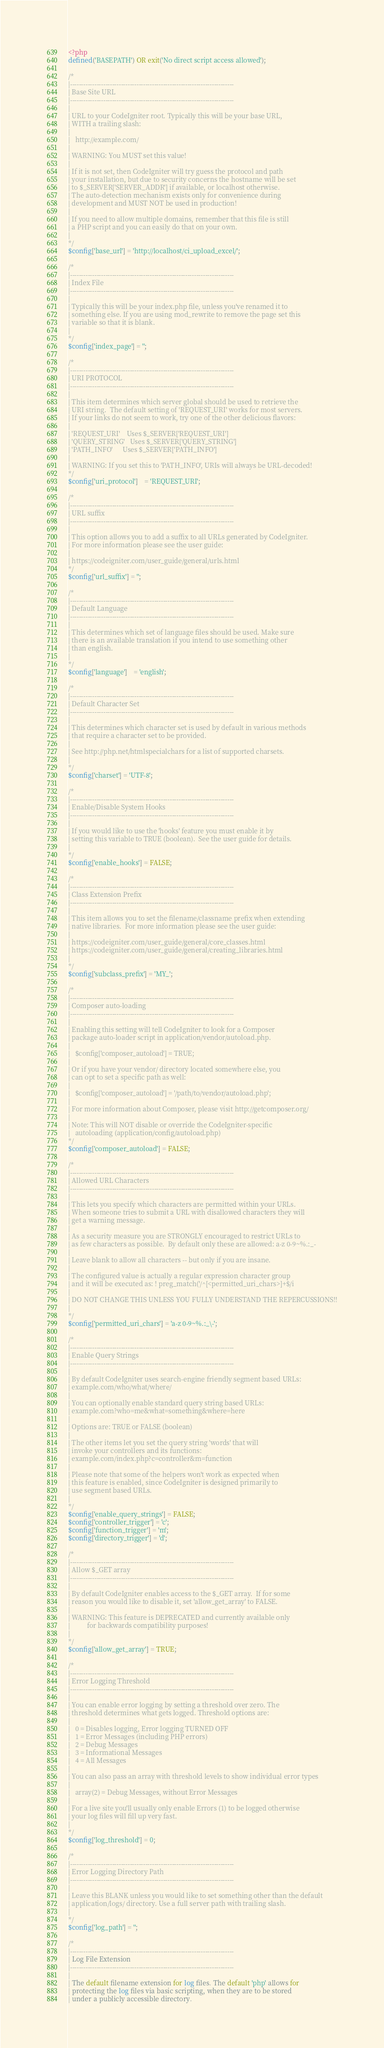Convert code to text. <code><loc_0><loc_0><loc_500><loc_500><_PHP_><?php
defined('BASEPATH') OR exit('No direct script access allowed');

/*
|--------------------------------------------------------------------------
| Base Site URL
|--------------------------------------------------------------------------
|
| URL to your CodeIgniter root. Typically this will be your base URL,
| WITH a trailing slash:
|
|	http://example.com/
|
| WARNING: You MUST set this value!
|
| If it is not set, then CodeIgniter will try guess the protocol and path
| your installation, but due to security concerns the hostname will be set
| to $_SERVER['SERVER_ADDR'] if available, or localhost otherwise.
| The auto-detection mechanism exists only for convenience during
| development and MUST NOT be used in production!
|
| If you need to allow multiple domains, remember that this file is still
| a PHP script and you can easily do that on your own.
|
*/
$config['base_url'] = 'http://localhost/ci_upload_excel/';

/*
|--------------------------------------------------------------------------
| Index File
|--------------------------------------------------------------------------
|
| Typically this will be your index.php file, unless you've renamed it to
| something else. If you are using mod_rewrite to remove the page set this
| variable so that it is blank.
|
*/
$config['index_page'] = '';

/*
|--------------------------------------------------------------------------
| URI PROTOCOL
|--------------------------------------------------------------------------
|
| This item determines which server global should be used to retrieve the
| URI string.  The default setting of 'REQUEST_URI' works for most servers.
| If your links do not seem to work, try one of the other delicious flavors:
|
| 'REQUEST_URI'    Uses $_SERVER['REQUEST_URI']
| 'QUERY_STRING'   Uses $_SERVER['QUERY_STRING']
| 'PATH_INFO'      Uses $_SERVER['PATH_INFO']
|
| WARNING: If you set this to 'PATH_INFO', URIs will always be URL-decoded!
*/
$config['uri_protocol']	= 'REQUEST_URI';

/*
|--------------------------------------------------------------------------
| URL suffix
|--------------------------------------------------------------------------
|
| This option allows you to add a suffix to all URLs generated by CodeIgniter.
| For more information please see the user guide:
|
| https://codeigniter.com/user_guide/general/urls.html
*/
$config['url_suffix'] = '';

/*
|--------------------------------------------------------------------------
| Default Language
|--------------------------------------------------------------------------
|
| This determines which set of language files should be used. Make sure
| there is an available translation if you intend to use something other
| than english.
|
*/
$config['language']	= 'english';

/*
|--------------------------------------------------------------------------
| Default Character Set
|--------------------------------------------------------------------------
|
| This determines which character set is used by default in various methods
| that require a character set to be provided.
|
| See http://php.net/htmlspecialchars for a list of supported charsets.
|
*/
$config['charset'] = 'UTF-8';

/*
|--------------------------------------------------------------------------
| Enable/Disable System Hooks
|--------------------------------------------------------------------------
|
| If you would like to use the 'hooks' feature you must enable it by
| setting this variable to TRUE (boolean).  See the user guide for details.
|
*/
$config['enable_hooks'] = FALSE;

/*
|--------------------------------------------------------------------------
| Class Extension Prefix
|--------------------------------------------------------------------------
|
| This item allows you to set the filename/classname prefix when extending
| native libraries.  For more information please see the user guide:
|
| https://codeigniter.com/user_guide/general/core_classes.html
| https://codeigniter.com/user_guide/general/creating_libraries.html
|
*/
$config['subclass_prefix'] = 'MY_';

/*
|--------------------------------------------------------------------------
| Composer auto-loading
|--------------------------------------------------------------------------
|
| Enabling this setting will tell CodeIgniter to look for a Composer
| package auto-loader script in application/vendor/autoload.php.
|
|	$config['composer_autoload'] = TRUE;
|
| Or if you have your vendor/ directory located somewhere else, you
| can opt to set a specific path as well:
|
|	$config['composer_autoload'] = '/path/to/vendor/autoload.php';
|
| For more information about Composer, please visit http://getcomposer.org/
|
| Note: This will NOT disable or override the CodeIgniter-specific
|	autoloading (application/config/autoload.php)
*/
$config['composer_autoload'] = FALSE;

/*
|--------------------------------------------------------------------------
| Allowed URL Characters
|--------------------------------------------------------------------------
|
| This lets you specify which characters are permitted within your URLs.
| When someone tries to submit a URL with disallowed characters they will
| get a warning message.
|
| As a security measure you are STRONGLY encouraged to restrict URLs to
| as few characters as possible.  By default only these are allowed: a-z 0-9~%.:_-
|
| Leave blank to allow all characters -- but only if you are insane.
|
| The configured value is actually a regular expression character group
| and it will be executed as: ! preg_match('/^[<permitted_uri_chars>]+$/i
|
| DO NOT CHANGE THIS UNLESS YOU FULLY UNDERSTAND THE REPERCUSSIONS!!
|
*/
$config['permitted_uri_chars'] = 'a-z 0-9~%.:_\-';

/*
|--------------------------------------------------------------------------
| Enable Query Strings
|--------------------------------------------------------------------------
|
| By default CodeIgniter uses search-engine friendly segment based URLs:
| example.com/who/what/where/
|
| You can optionally enable standard query string based URLs:
| example.com?who=me&what=something&where=here
|
| Options are: TRUE or FALSE (boolean)
|
| The other items let you set the query string 'words' that will
| invoke your controllers and its functions:
| example.com/index.php?c=controller&m=function
|
| Please note that some of the helpers won't work as expected when
| this feature is enabled, since CodeIgniter is designed primarily to
| use segment based URLs.
|
*/
$config['enable_query_strings'] = FALSE;
$config['controller_trigger'] = 'c';
$config['function_trigger'] = 'm';
$config['directory_trigger'] = 'd';

/*
|--------------------------------------------------------------------------
| Allow $_GET array
|--------------------------------------------------------------------------
|
| By default CodeIgniter enables access to the $_GET array.  If for some
| reason you would like to disable it, set 'allow_get_array' to FALSE.
|
| WARNING: This feature is DEPRECATED and currently available only
|          for backwards compatibility purposes!
|
*/
$config['allow_get_array'] = TRUE;

/*
|--------------------------------------------------------------------------
| Error Logging Threshold
|--------------------------------------------------------------------------
|
| You can enable error logging by setting a threshold over zero. The
| threshold determines what gets logged. Threshold options are:
|
|	0 = Disables logging, Error logging TURNED OFF
|	1 = Error Messages (including PHP errors)
|	2 = Debug Messages
|	3 = Informational Messages
|	4 = All Messages
|
| You can also pass an array with threshold levels to show individual error types
|
| 	array(2) = Debug Messages, without Error Messages
|
| For a live site you'll usually only enable Errors (1) to be logged otherwise
| your log files will fill up very fast.
|
*/
$config['log_threshold'] = 0;

/*
|--------------------------------------------------------------------------
| Error Logging Directory Path
|--------------------------------------------------------------------------
|
| Leave this BLANK unless you would like to set something other than the default
| application/logs/ directory. Use a full server path with trailing slash.
|
*/
$config['log_path'] = '';

/*
|--------------------------------------------------------------------------
| Log File Extension
|--------------------------------------------------------------------------
|
| The default filename extension for log files. The default 'php' allows for
| protecting the log files via basic scripting, when they are to be stored
| under a publicly accessible directory.</code> 